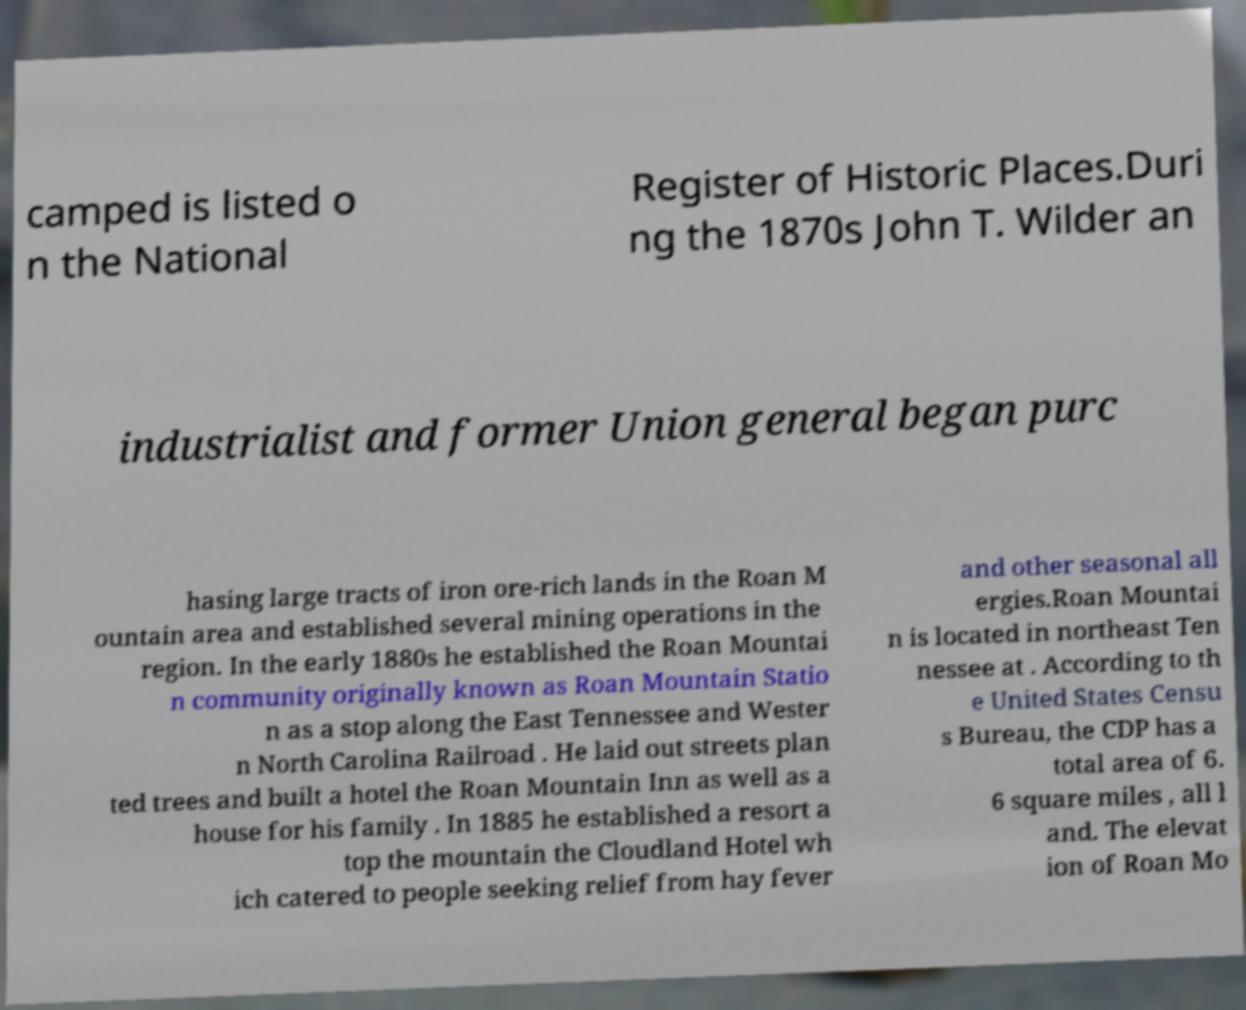I need the written content from this picture converted into text. Can you do that? camped is listed o n the National Register of Historic Places.Duri ng the 1870s John T. Wilder an industrialist and former Union general began purc hasing large tracts of iron ore-rich lands in the Roan M ountain area and established several mining operations in the region. In the early 1880s he established the Roan Mountai n community originally known as Roan Mountain Statio n as a stop along the East Tennessee and Wester n North Carolina Railroad . He laid out streets plan ted trees and built a hotel the Roan Mountain Inn as well as a house for his family . In 1885 he established a resort a top the mountain the Cloudland Hotel wh ich catered to people seeking relief from hay fever and other seasonal all ergies.Roan Mountai n is located in northeast Ten nessee at . According to th e United States Censu s Bureau, the CDP has a total area of 6. 6 square miles , all l and. The elevat ion of Roan Mo 